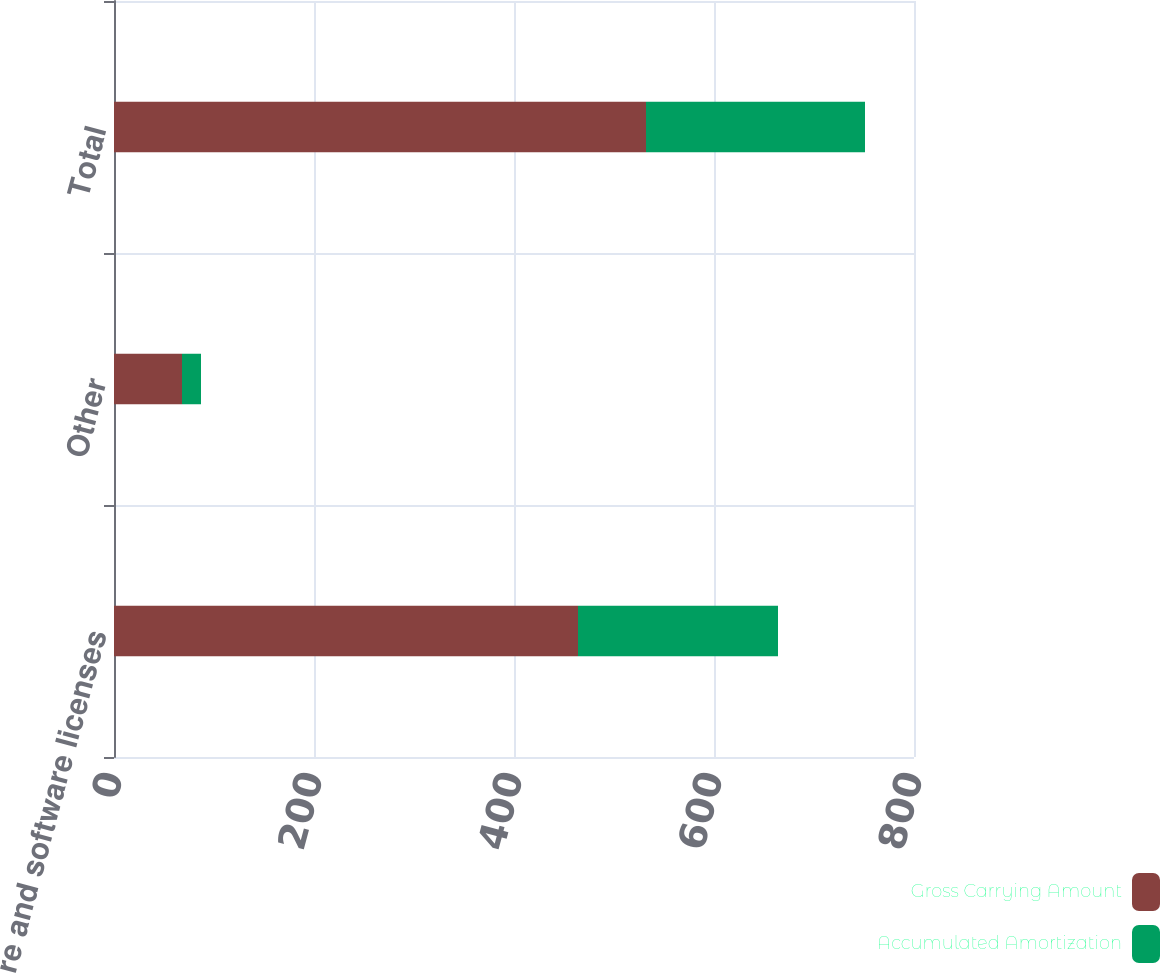Convert chart to OTSL. <chart><loc_0><loc_0><loc_500><loc_500><stacked_bar_chart><ecel><fcel>Software and software licenses<fcel>Other<fcel>Total<nl><fcel>Gross Carrying Amount<fcel>464<fcel>68<fcel>532<nl><fcel>Accumulated Amortization<fcel>200<fcel>19<fcel>219<nl></chart> 